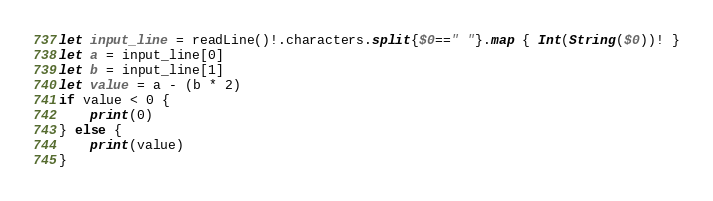<code> <loc_0><loc_0><loc_500><loc_500><_Swift_>let input_line = readLine()!.characters.split{$0==" "}.map { Int(String($0))! }
let a = input_line[0]
let b = input_line[1]
let value = a - (b * 2)
if value < 0 {
	print(0)
} else {
	print(value)
}</code> 